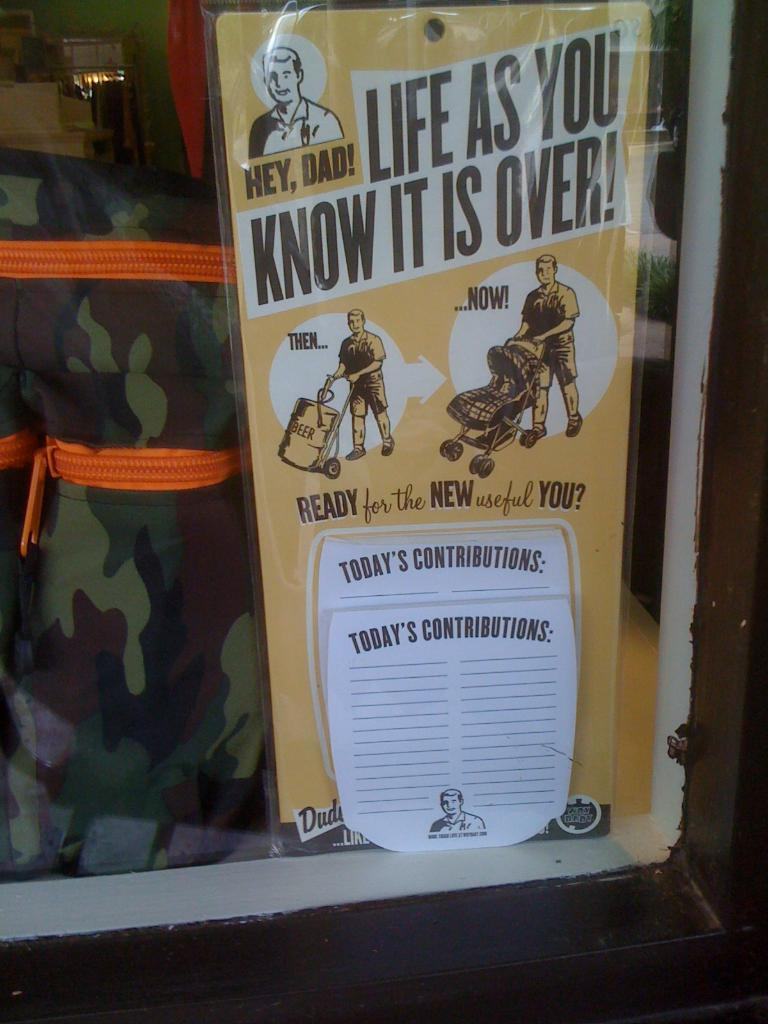<image>
Give a short and clear explanation of the subsequent image. a poster inside a window that says 'life as you know it is over' 